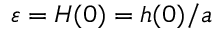<formula> <loc_0><loc_0><loc_500><loc_500>\varepsilon = H ( 0 ) = h ( 0 ) / a</formula> 